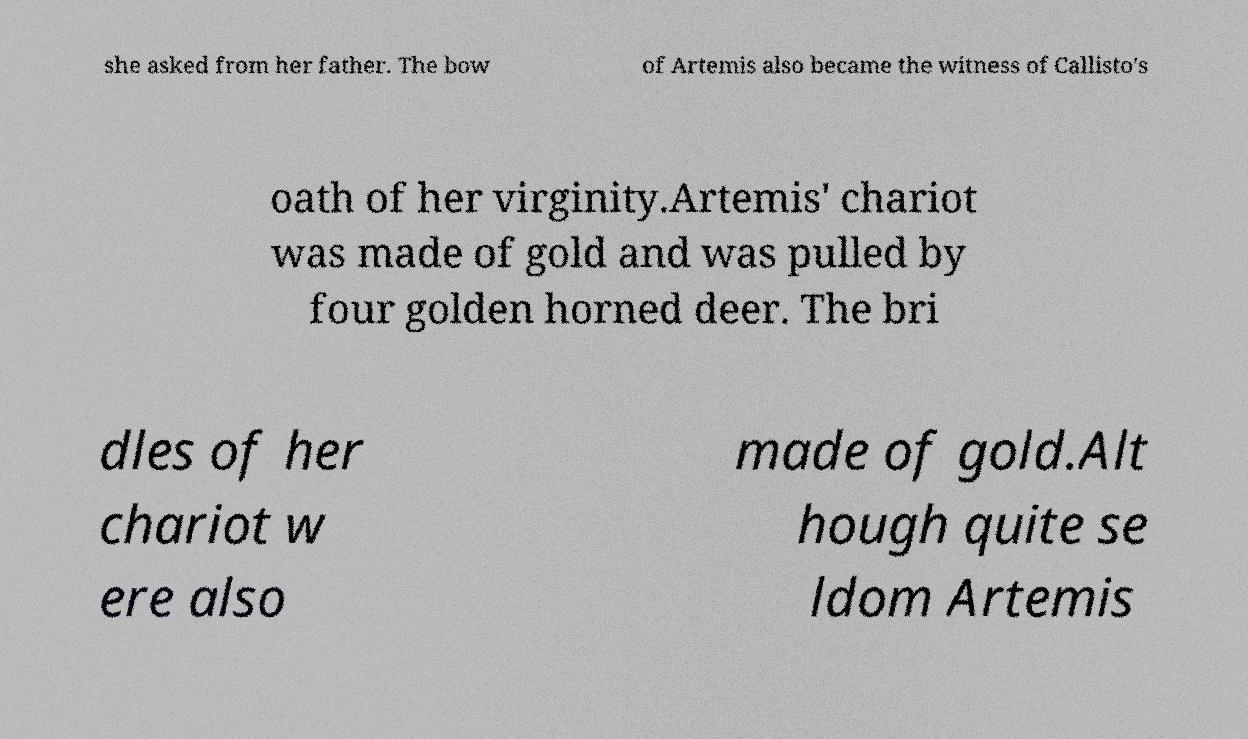There's text embedded in this image that I need extracted. Can you transcribe it verbatim? she asked from her father. The bow of Artemis also became the witness of Callisto's oath of her virginity.Artemis' chariot was made of gold and was pulled by four golden horned deer. The bri dles of her chariot w ere also made of gold.Alt hough quite se ldom Artemis 